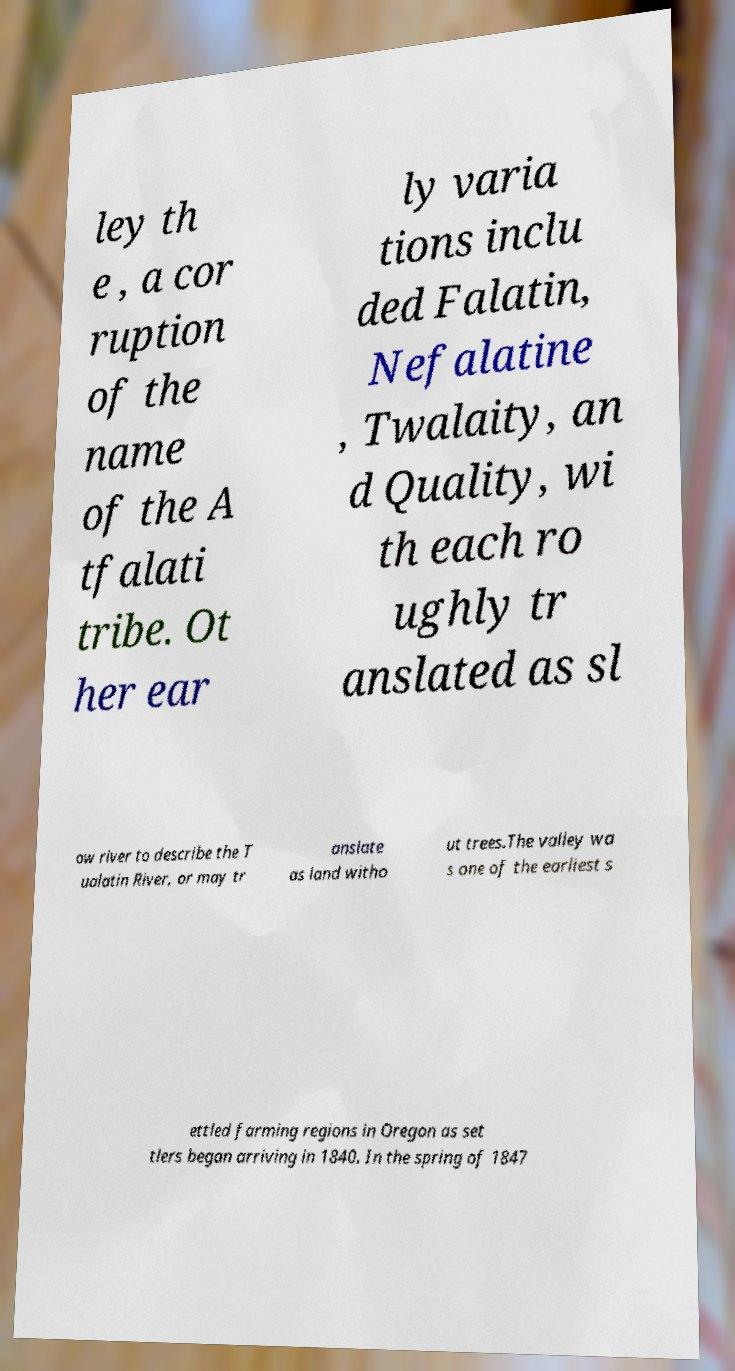For documentation purposes, I need the text within this image transcribed. Could you provide that? ley th e , a cor ruption of the name of the A tfalati tribe. Ot her ear ly varia tions inclu ded Falatin, Nefalatine , Twalaity, an d Quality, wi th each ro ughly tr anslated as sl ow river to describe the T ualatin River, or may tr anslate as land witho ut trees.The valley wa s one of the earliest s ettled farming regions in Oregon as set tlers began arriving in 1840. In the spring of 1847 